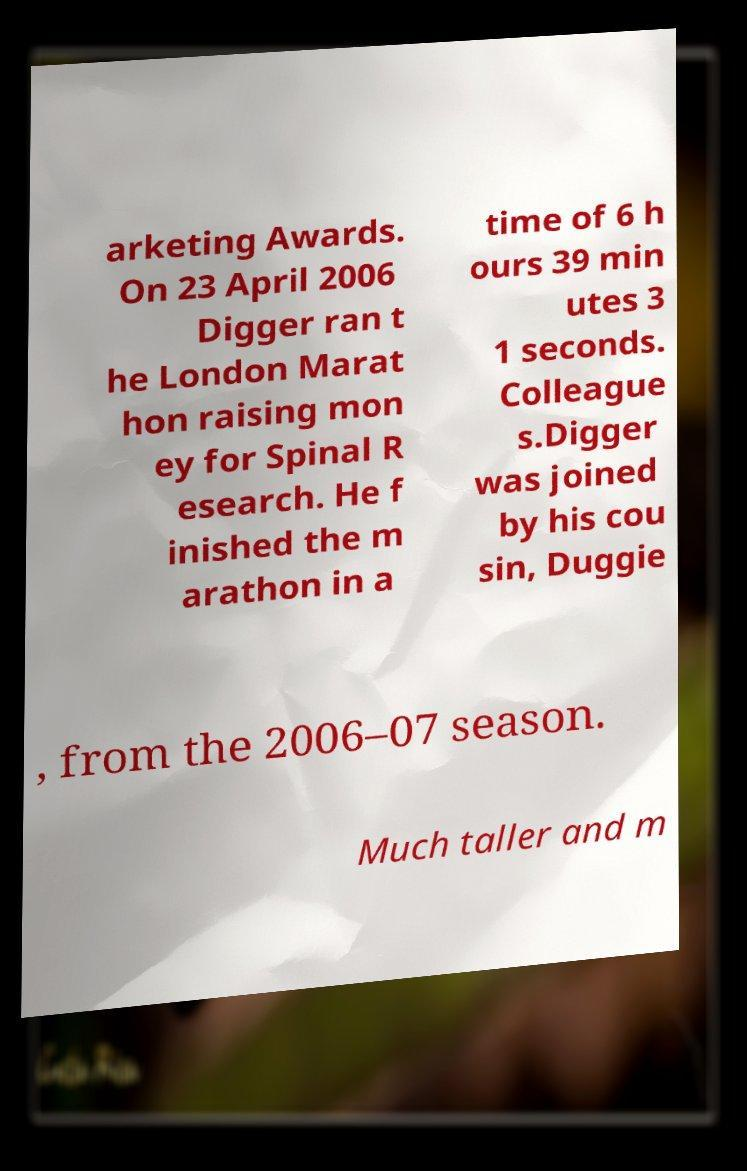Please read and relay the text visible in this image. What does it say? arketing Awards. On 23 April 2006 Digger ran t he London Marat hon raising mon ey for Spinal R esearch. He f inished the m arathon in a time of 6 h ours 39 min utes 3 1 seconds. Colleague s.Digger was joined by his cou sin, Duggie , from the 2006–07 season. Much taller and m 